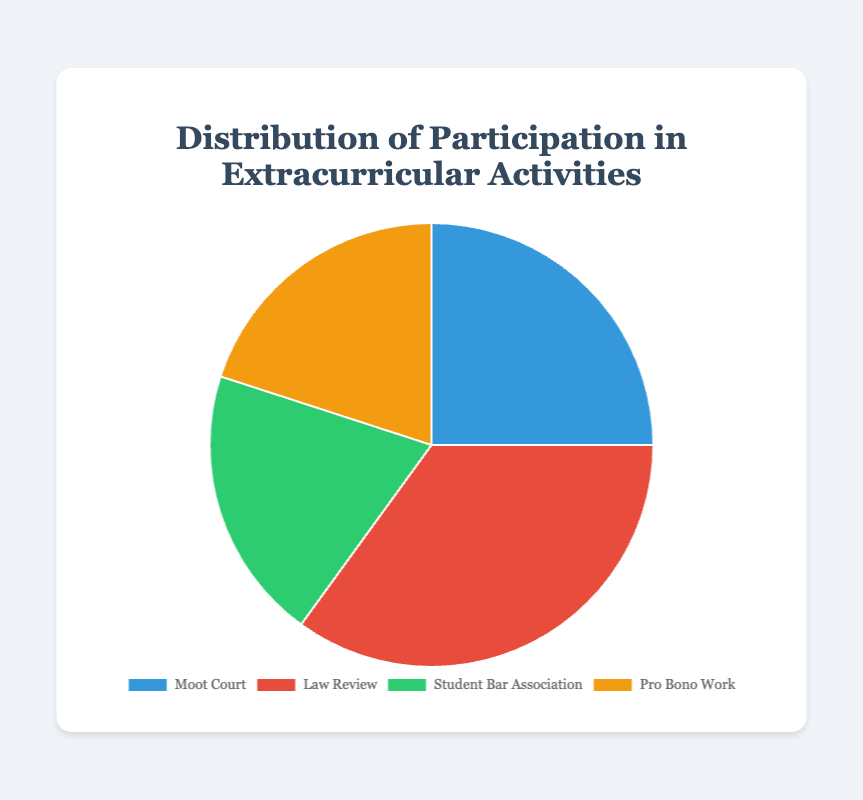What percentage of participants are involved in Moot Court? The chart provides the number of participants in Moot Court as 25. The total number of participants across all activities is 25 + 35 + 20 + 20 = 100. To find the percentage, use (25 / 100) * 100 = 25%.
Answer: 25% Which activity has the highest number of participants? Looking at the chart, Law Review has the highest number of participants with 35.
Answer: Law Review How does the number of participants in Pro Bono Work compare to those in Moot Court? Both Pro Bono Work and Moot Court have 20 and 25 participants respectively. Moot Court has 5 more participants than Pro Bono Work.
Answer: Moot Court has 5 more participants What are the combined percentages of participants in Student Bar Association and Pro Bono Work? The number of participants in both Student Bar Association and Pro Bono Work is 20 each, making it a total of 20 + 20 = 40. The total number of participants is 100. Thus, the combined percentage is (40 / 100) * 100 = 40%.
Answer: 40% Which extracurricular activity is represented by the green color in the chart? Based on the chart's visual attributes, the green segment corresponds to the Student Bar Association.
Answer: Student Bar Association What is the difference in number of participants between Law Review and Student Bar Association? Law Review has 35 participants, while the Student Bar Association has 20. The difference is 35 - 20 = 15.
Answer: 15 participants If you combine the participants of the two least popular activities, what is the total? The two least popular activities are Pro Bono Work and Student Bar Association, both with 20 participants each. The combined total is 20 + 20 = 40.
Answer: 40 participants What is the percentage of participants in activities other than Law Review? The total number of participants in activities other than Law Review is 25 (Moot Court) + 20 (Student Bar Association) + 20 (Pro Bono Work) = 65. The percentage is (65 / 100) * 100 = 65%.
Answer: 65% Which activity has more participants: Moot Court or Student Bar Association? Moot Court has 25 participants while Student Bar Association has 20, so Moot Court has more participants.
Answer: Moot Court 